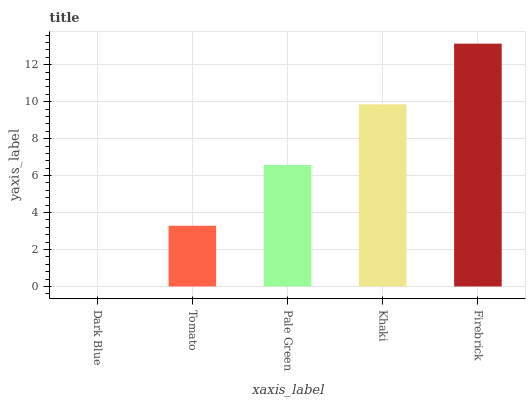Is Tomato the minimum?
Answer yes or no. No. Is Tomato the maximum?
Answer yes or no. No. Is Tomato greater than Dark Blue?
Answer yes or no. Yes. Is Dark Blue less than Tomato?
Answer yes or no. Yes. Is Dark Blue greater than Tomato?
Answer yes or no. No. Is Tomato less than Dark Blue?
Answer yes or no. No. Is Pale Green the high median?
Answer yes or no. Yes. Is Pale Green the low median?
Answer yes or no. Yes. Is Khaki the high median?
Answer yes or no. No. Is Tomato the low median?
Answer yes or no. No. 